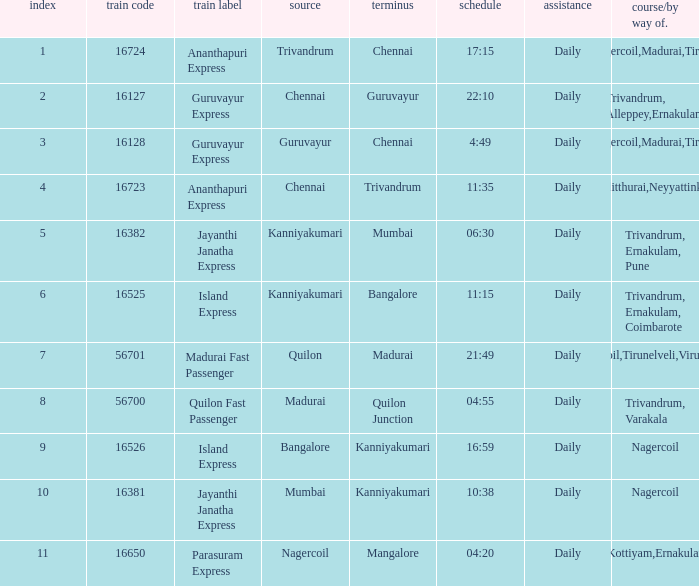What is the route/via when the train name is Parasuram Express? Trivandrum,Kottiyam,Ernakulam,Kozhikode. 